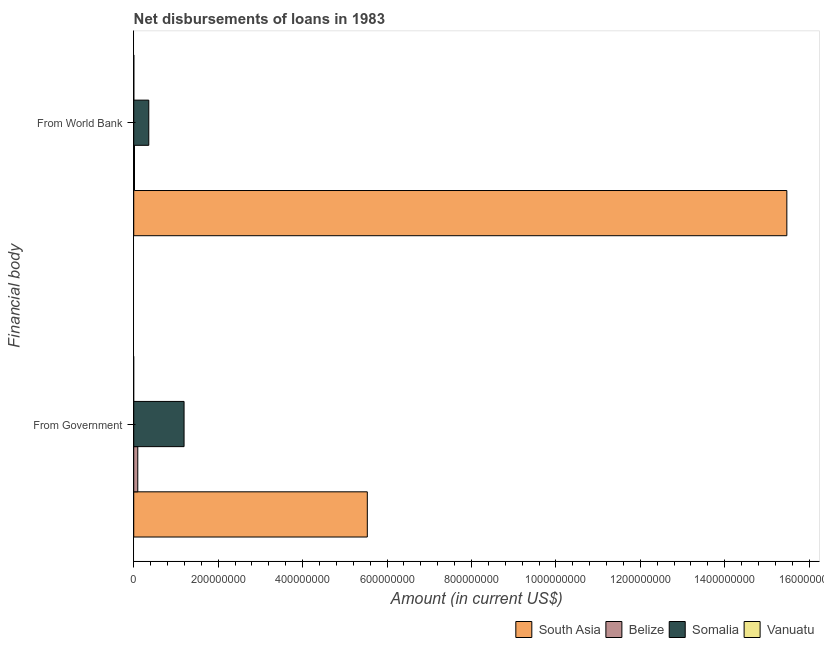How many different coloured bars are there?
Give a very brief answer. 4. How many groups of bars are there?
Keep it short and to the point. 2. How many bars are there on the 2nd tick from the top?
Offer a very short reply. 3. How many bars are there on the 1st tick from the bottom?
Your answer should be compact. 3. What is the label of the 2nd group of bars from the top?
Ensure brevity in your answer.  From Government. What is the net disbursements of loan from government in Somalia?
Offer a terse response. 1.19e+08. Across all countries, what is the maximum net disbursements of loan from world bank?
Your answer should be compact. 1.55e+09. Across all countries, what is the minimum net disbursements of loan from world bank?
Offer a terse response. 1.57e+05. In which country was the net disbursements of loan from government maximum?
Your answer should be compact. South Asia. What is the total net disbursements of loan from government in the graph?
Make the answer very short. 6.82e+08. What is the difference between the net disbursements of loan from world bank in South Asia and that in Vanuatu?
Ensure brevity in your answer.  1.55e+09. What is the difference between the net disbursements of loan from world bank in South Asia and the net disbursements of loan from government in Somalia?
Keep it short and to the point. 1.43e+09. What is the average net disbursements of loan from government per country?
Your answer should be very brief. 1.71e+08. What is the difference between the net disbursements of loan from government and net disbursements of loan from world bank in Belize?
Keep it short and to the point. 7.78e+06. In how many countries, is the net disbursements of loan from government greater than 680000000 US$?
Keep it short and to the point. 0. What is the ratio of the net disbursements of loan from world bank in Somalia to that in Belize?
Your answer should be very brief. 19.83. Is the net disbursements of loan from world bank in Belize less than that in Vanuatu?
Provide a succinct answer. No. How many bars are there?
Your answer should be compact. 7. Are all the bars in the graph horizontal?
Your answer should be compact. Yes. Does the graph contain any zero values?
Give a very brief answer. Yes. Does the graph contain grids?
Provide a short and direct response. No. How many legend labels are there?
Your answer should be very brief. 4. How are the legend labels stacked?
Keep it short and to the point. Horizontal. What is the title of the graph?
Provide a succinct answer. Net disbursements of loans in 1983. What is the label or title of the Y-axis?
Provide a succinct answer. Financial body. What is the Amount (in current US$) of South Asia in From Government?
Give a very brief answer. 5.53e+08. What is the Amount (in current US$) in Belize in From Government?
Offer a terse response. 9.58e+06. What is the Amount (in current US$) in Somalia in From Government?
Provide a short and direct response. 1.19e+08. What is the Amount (in current US$) of Vanuatu in From Government?
Provide a succinct answer. 0. What is the Amount (in current US$) in South Asia in From World Bank?
Provide a short and direct response. 1.55e+09. What is the Amount (in current US$) in Belize in From World Bank?
Make the answer very short. 1.80e+06. What is the Amount (in current US$) of Somalia in From World Bank?
Give a very brief answer. 3.56e+07. What is the Amount (in current US$) in Vanuatu in From World Bank?
Your answer should be compact. 1.57e+05. Across all Financial body, what is the maximum Amount (in current US$) of South Asia?
Your answer should be very brief. 1.55e+09. Across all Financial body, what is the maximum Amount (in current US$) in Belize?
Provide a short and direct response. 9.58e+06. Across all Financial body, what is the maximum Amount (in current US$) of Somalia?
Your response must be concise. 1.19e+08. Across all Financial body, what is the maximum Amount (in current US$) in Vanuatu?
Give a very brief answer. 1.57e+05. Across all Financial body, what is the minimum Amount (in current US$) of South Asia?
Your answer should be compact. 5.53e+08. Across all Financial body, what is the minimum Amount (in current US$) of Belize?
Keep it short and to the point. 1.80e+06. Across all Financial body, what is the minimum Amount (in current US$) of Somalia?
Offer a terse response. 3.56e+07. Across all Financial body, what is the minimum Amount (in current US$) in Vanuatu?
Ensure brevity in your answer.  0. What is the total Amount (in current US$) of South Asia in the graph?
Give a very brief answer. 2.10e+09. What is the total Amount (in current US$) of Belize in the graph?
Give a very brief answer. 1.14e+07. What is the total Amount (in current US$) of Somalia in the graph?
Your answer should be compact. 1.55e+08. What is the total Amount (in current US$) of Vanuatu in the graph?
Make the answer very short. 1.57e+05. What is the difference between the Amount (in current US$) of South Asia in From Government and that in From World Bank?
Offer a terse response. -9.94e+08. What is the difference between the Amount (in current US$) in Belize in From Government and that in From World Bank?
Offer a terse response. 7.78e+06. What is the difference between the Amount (in current US$) in Somalia in From Government and that in From World Bank?
Give a very brief answer. 8.36e+07. What is the difference between the Amount (in current US$) in South Asia in From Government and the Amount (in current US$) in Belize in From World Bank?
Make the answer very short. 5.51e+08. What is the difference between the Amount (in current US$) of South Asia in From Government and the Amount (in current US$) of Somalia in From World Bank?
Provide a succinct answer. 5.18e+08. What is the difference between the Amount (in current US$) of South Asia in From Government and the Amount (in current US$) of Vanuatu in From World Bank?
Your answer should be compact. 5.53e+08. What is the difference between the Amount (in current US$) of Belize in From Government and the Amount (in current US$) of Somalia in From World Bank?
Provide a short and direct response. -2.60e+07. What is the difference between the Amount (in current US$) of Belize in From Government and the Amount (in current US$) of Vanuatu in From World Bank?
Make the answer very short. 9.42e+06. What is the difference between the Amount (in current US$) of Somalia in From Government and the Amount (in current US$) of Vanuatu in From World Bank?
Your answer should be compact. 1.19e+08. What is the average Amount (in current US$) in South Asia per Financial body?
Offer a terse response. 1.05e+09. What is the average Amount (in current US$) of Belize per Financial body?
Offer a terse response. 5.69e+06. What is the average Amount (in current US$) in Somalia per Financial body?
Keep it short and to the point. 7.74e+07. What is the average Amount (in current US$) of Vanuatu per Financial body?
Your answer should be very brief. 7.85e+04. What is the difference between the Amount (in current US$) of South Asia and Amount (in current US$) of Belize in From Government?
Make the answer very short. 5.44e+08. What is the difference between the Amount (in current US$) of South Asia and Amount (in current US$) of Somalia in From Government?
Provide a succinct answer. 4.34e+08. What is the difference between the Amount (in current US$) in Belize and Amount (in current US$) in Somalia in From Government?
Offer a very short reply. -1.10e+08. What is the difference between the Amount (in current US$) of South Asia and Amount (in current US$) of Belize in From World Bank?
Your answer should be very brief. 1.55e+09. What is the difference between the Amount (in current US$) in South Asia and Amount (in current US$) in Somalia in From World Bank?
Offer a terse response. 1.51e+09. What is the difference between the Amount (in current US$) of South Asia and Amount (in current US$) of Vanuatu in From World Bank?
Give a very brief answer. 1.55e+09. What is the difference between the Amount (in current US$) of Belize and Amount (in current US$) of Somalia in From World Bank?
Ensure brevity in your answer.  -3.38e+07. What is the difference between the Amount (in current US$) of Belize and Amount (in current US$) of Vanuatu in From World Bank?
Your response must be concise. 1.64e+06. What is the difference between the Amount (in current US$) of Somalia and Amount (in current US$) of Vanuatu in From World Bank?
Make the answer very short. 3.55e+07. What is the ratio of the Amount (in current US$) of South Asia in From Government to that in From World Bank?
Offer a terse response. 0.36. What is the ratio of the Amount (in current US$) of Belize in From Government to that in From World Bank?
Give a very brief answer. 5.33. What is the ratio of the Amount (in current US$) in Somalia in From Government to that in From World Bank?
Provide a short and direct response. 3.35. What is the difference between the highest and the second highest Amount (in current US$) in South Asia?
Give a very brief answer. 9.94e+08. What is the difference between the highest and the second highest Amount (in current US$) of Belize?
Your response must be concise. 7.78e+06. What is the difference between the highest and the second highest Amount (in current US$) of Somalia?
Keep it short and to the point. 8.36e+07. What is the difference between the highest and the lowest Amount (in current US$) in South Asia?
Give a very brief answer. 9.94e+08. What is the difference between the highest and the lowest Amount (in current US$) of Belize?
Ensure brevity in your answer.  7.78e+06. What is the difference between the highest and the lowest Amount (in current US$) of Somalia?
Ensure brevity in your answer.  8.36e+07. What is the difference between the highest and the lowest Amount (in current US$) of Vanuatu?
Keep it short and to the point. 1.57e+05. 